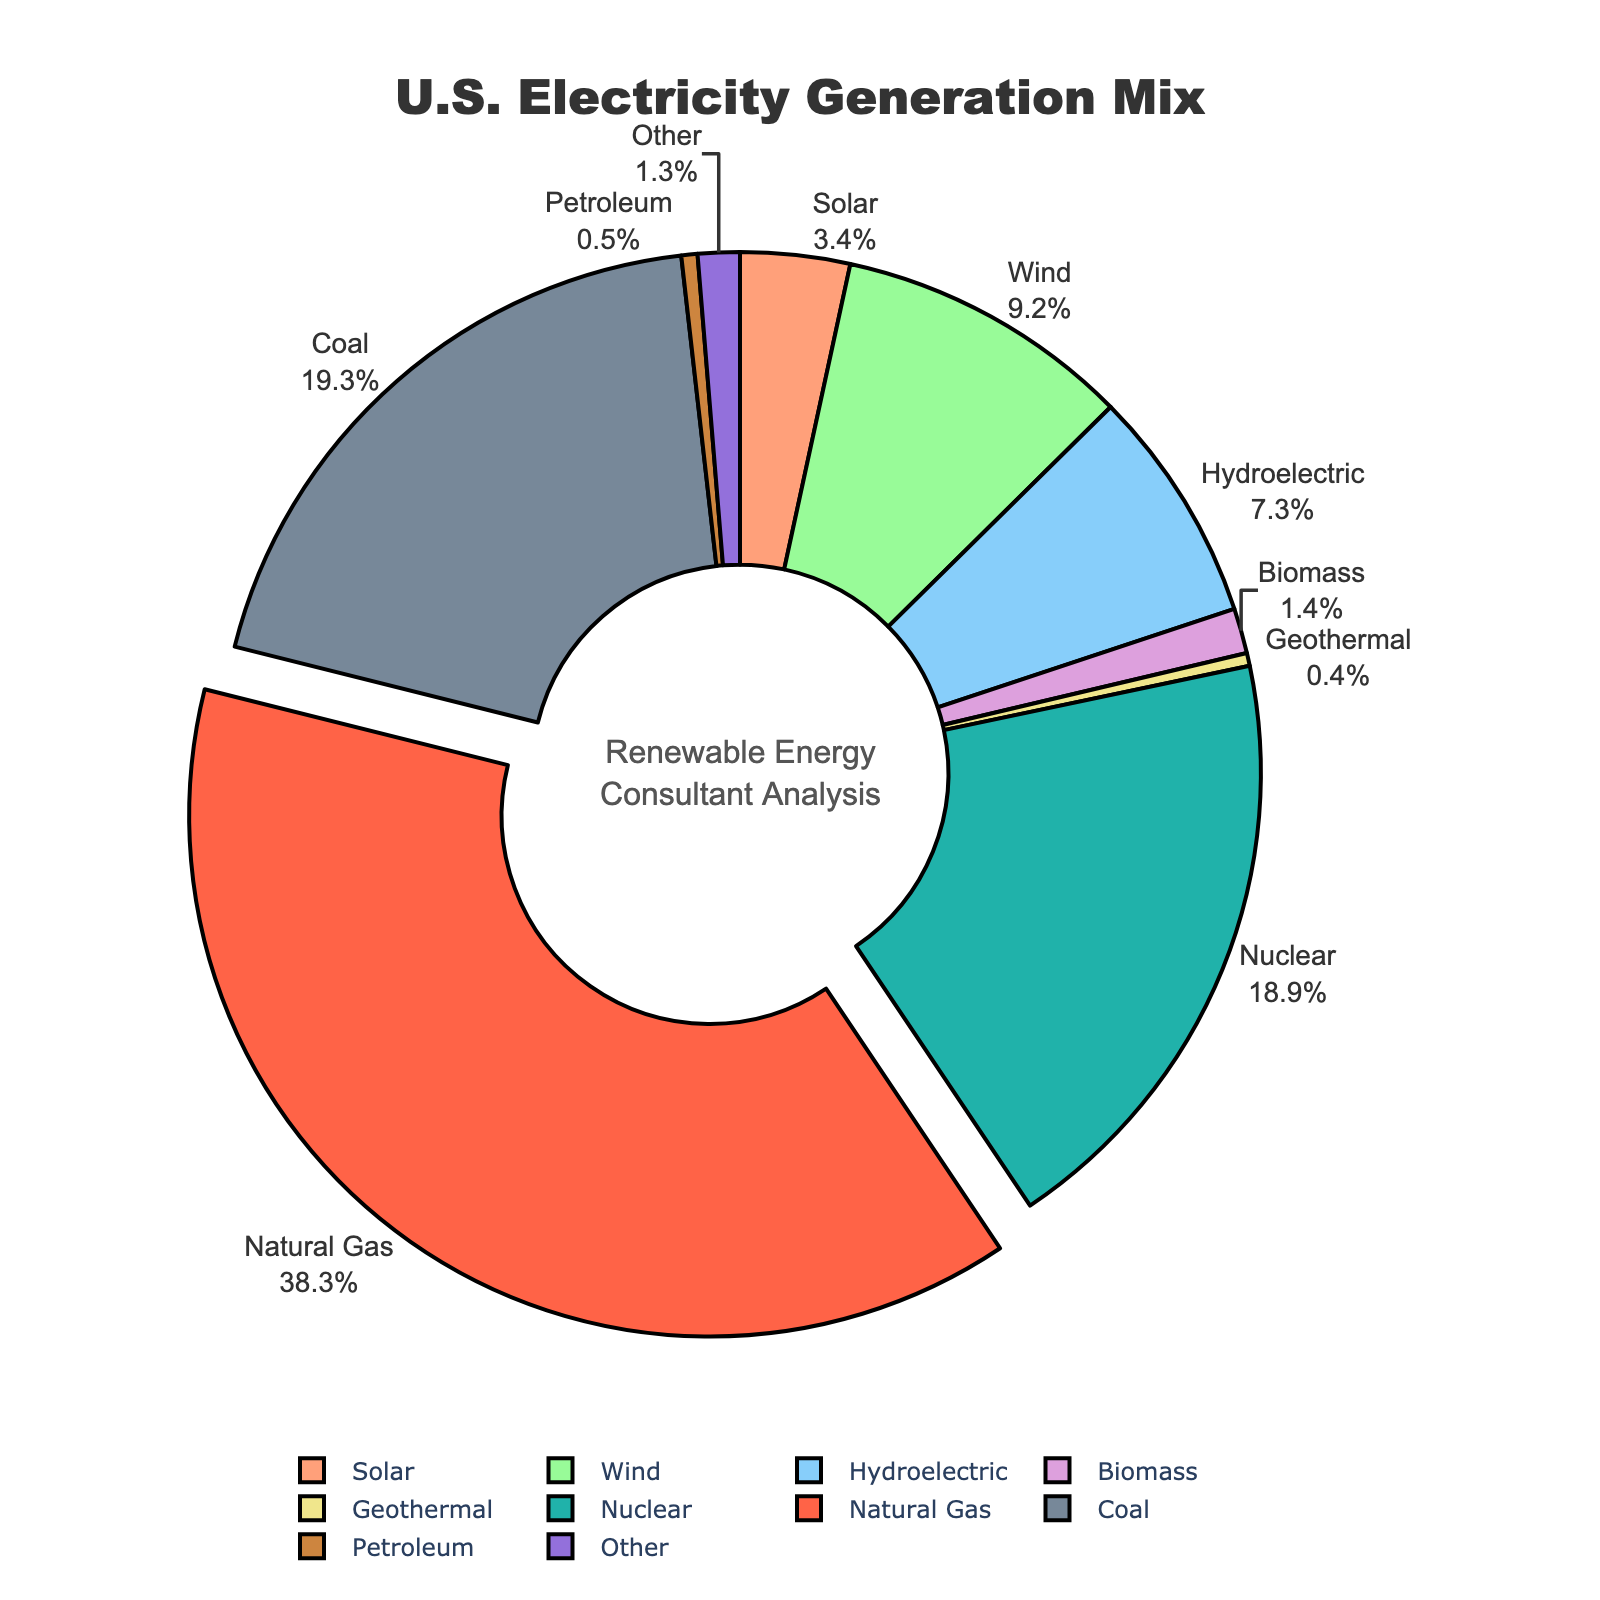What percentage of the U.S. electricity generation mix is from renewable sources, including Solar, Wind, Hydroelectric, Biomass, and Geothermal? First, sum the percentages of Solar (3.4%), Wind (9.2%), Hydroelectric (7.3%), Biomass (1.4%), and Geothermal (0.4%). The total is 3.4 + 9.2 + 7.3 + 1.4 + 0.4 = 21.7%
Answer: 21.7% Which energy source contributes the most to U.S. electricity generation? Look at the section pulled out from the pie chart which highlights the energy source with the highest percentage. Natural Gas has the largest segment at 38.3%
Answer: Natural Gas What two segments combined form approximately half of the U.S. electricity generation mix? Pair the segments with the largest percentages: Natural Gas (38.3%) and Coal (19.3%). Their combined percentage is 38.3 + 19.3 = 57.6%, which is more than half of the total.
Answer: Natural Gas and Coal Is the percentage of electricity generated from Nuclear higher or lower than that from Coal? Compare the sizes of the segments for Nuclear (18.9%) and Coal (19.3%). The Coal segment is slightly larger.
Answer: Lower Which renewable energy source has the smallest share in the U.S. electricity generation mix? Look for the smallest segment among renewables, which is Geothermal, at 0.4%
Answer: Geothermal How much larger is the contribution from Wind compared to Solar energy? Subtract the Solar percentage from the Wind percentage. Wind is 9.2% and Solar is 3.4%, so the difference is 9.2 - 3.4 = 5.8%
Answer: 5.8% What is the combined percentage of non-renewable sources (Natural Gas, Coal, Petroleum, Nuclear, and Other)? Sum the percentages of Natural Gas (38.3%), Coal (19.3%), Petroleum (0.5%), Nuclear (18.9%), and Other (1.3%). The total is 38.3 + 19.3 + 0.5 + 18.9 + 1.3 = 78.3%
Answer: 78.3% Among renewable energy sources, which has the second-largest share of the electricity generation mix? Compare the segments for each renewable source. Wind has the highest at 9.2%, and Hydroelectric is the second largest at 7.3%
Answer: Hydroelectric What visual element helps to identify the highest contributing energy source in the pie chart? The section pulled out from the pie chart indicates the largest contributor.
Answer: Pulled-out section How do the contributions of Biomass and Petroleum compare? Compare the sizes and labels of the pie chart segments. Biomass contributes 1.4%, while Petroleum contributes 0.5%, so Biomass is larger.
Answer: Biomass is larger 